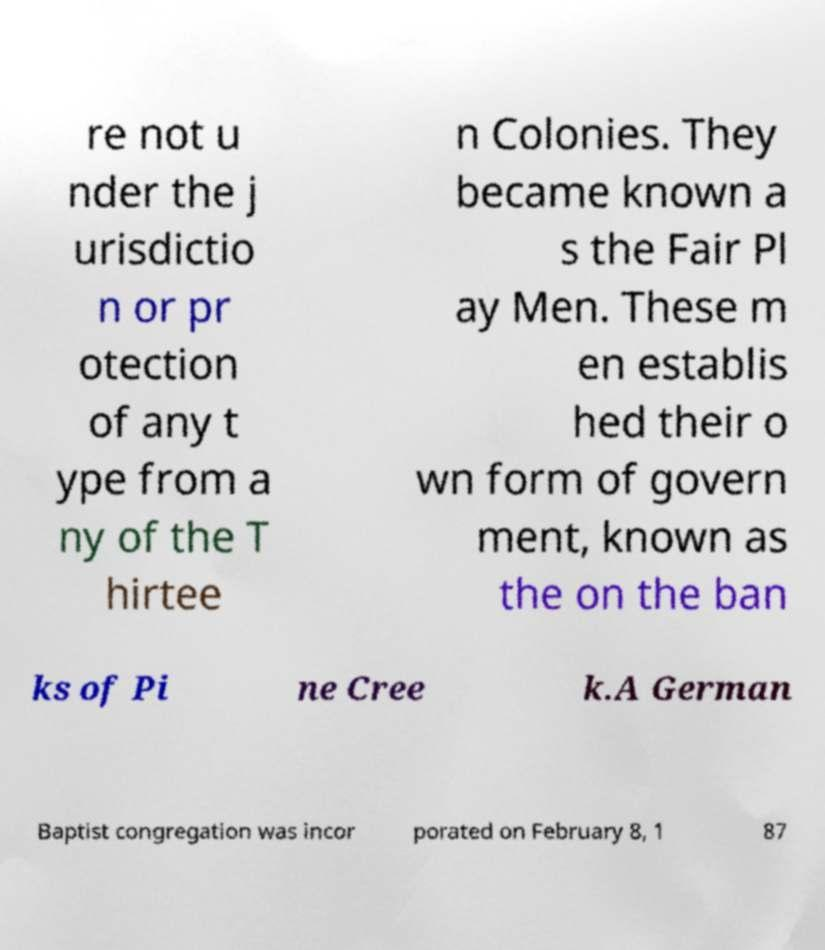Please identify and transcribe the text found in this image. re not u nder the j urisdictio n or pr otection of any t ype from a ny of the T hirtee n Colonies. They became known a s the Fair Pl ay Men. These m en establis hed their o wn form of govern ment, known as the on the ban ks of Pi ne Cree k.A German Baptist congregation was incor porated on February 8, 1 87 